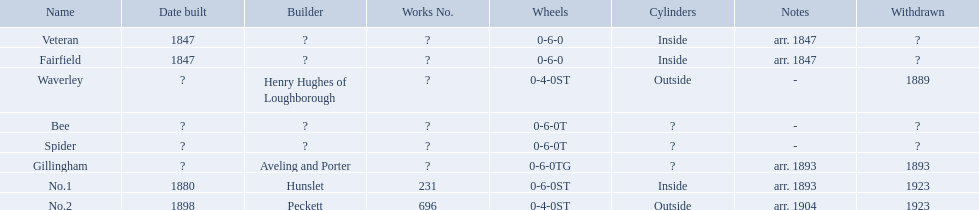Which have established built dates? Veteran, Fairfield, No.1, No.2. What additional structure was built in 1847? Veteran. What is the alderney railway called? Veteran, Fairfield, Waverley, Bee, Spider, Gillingham, No.1, No.2. When was the farfield established? 1847. What additional constructions happened that year? Veteran. Which possess known construction dates? Veteran, Fairfield, No.1, No.2. What other edifice was erected in 1847? Veteran. What are the names associated with the alderney railway? Veteran, Fairfield, Waverley, Bee, Spider, Gillingham, No.1, No.2. When was the farfield constructed? 1847. Can you give me this table in json format? {'header': ['Name', 'Date built', 'Builder', 'Works No.', 'Wheels', 'Cylinders', 'Notes', 'Withdrawn'], 'rows': [['Veteran', '1847', '?', '?', '0-6-0', 'Inside', 'arr. 1847', '?'], ['Fairfield', '1847', '?', '?', '0-6-0', 'Inside', 'arr. 1847', '?'], ['Waverley', '?', 'Henry Hughes of Loughborough', '?', '0-4-0ST', 'Outside', '-', '1889'], ['Bee', '?', '?', '?', '0-6-0T', '?', '-', '?'], ['Spider', '?', '?', '?', '0-6-0T', '?', '-', '?'], ['Gillingham', '?', 'Aveling and Porter', '?', '0-6-0TG', '?', 'arr. 1893', '1893'], ['No.1', '1880', 'Hunslet', '231', '0-6-0ST', 'Inside', 'arr. 1893', '1923'], ['No.2', '1898', 'Peckett', '696', '0-4-0ST', 'Outside', 'arr. 1904', '1923']]} What other structures were built during that same year? Veteran. Parse the full table in json format. {'header': ['Name', 'Date built', 'Builder', 'Works No.', 'Wheels', 'Cylinders', 'Notes', 'Withdrawn'], 'rows': [['Veteran', '1847', '?', '?', '0-6-0', 'Inside', 'arr. 1847', '?'], ['Fairfield', '1847', '?', '?', '0-6-0', 'Inside', 'arr. 1847', '?'], ['Waverley', '?', 'Henry Hughes of Loughborough', '?', '0-4-0ST', 'Outside', '-', '1889'], ['Bee', '?', '?', '?', '0-6-0T', '?', '-', '?'], ['Spider', '?', '?', '?', '0-6-0T', '?', '-', '?'], ['Gillingham', '?', 'Aveling and Porter', '?', '0-6-0TG', '?', 'arr. 1893', '1893'], ['No.1', '1880', 'Hunslet', '231', '0-6-0ST', 'Inside', 'arr. 1893', '1923'], ['No.2', '1898', 'Peckett', '696', '0-4-0ST', 'Outside', 'arr. 1904', '1923']]} What structures have confirmed construction dates? Veteran, Fairfield, No.1, No.2. Which additional one was constructed in 1847? Veteran. Which buildings have established construction years? Veteran, Fairfield, No.1, No.2. What other structure was completed in 1847? Veteran. Could you help me parse every detail presented in this table? {'header': ['Name', 'Date built', 'Builder', 'Works No.', 'Wheels', 'Cylinders', 'Notes', 'Withdrawn'], 'rows': [['Veteran', '1847', '?', '?', '0-6-0', 'Inside', 'arr. 1847', '?'], ['Fairfield', '1847', '?', '?', '0-6-0', 'Inside', 'arr. 1847', '?'], ['Waverley', '?', 'Henry Hughes of Loughborough', '?', '0-4-0ST', 'Outside', '-', '1889'], ['Bee', '?', '?', '?', '0-6-0T', '?', '-', '?'], ['Spider', '?', '?', '?', '0-6-0T', '?', '-', '?'], ['Gillingham', '?', 'Aveling and Porter', '?', '0-6-0TG', '?', 'arr. 1893', '1893'], ['No.1', '1880', 'Hunslet', '231', '0-6-0ST', 'Inside', 'arr. 1893', '1923'], ['No.2', '1898', 'Peckett', '696', '0-4-0ST', 'Outside', 'arr. 1904', '1923']]} What edifices have documented dates of completion? Veteran, Fairfield, No.1, No.2. Which other building was erected in 1847? Veteran. 